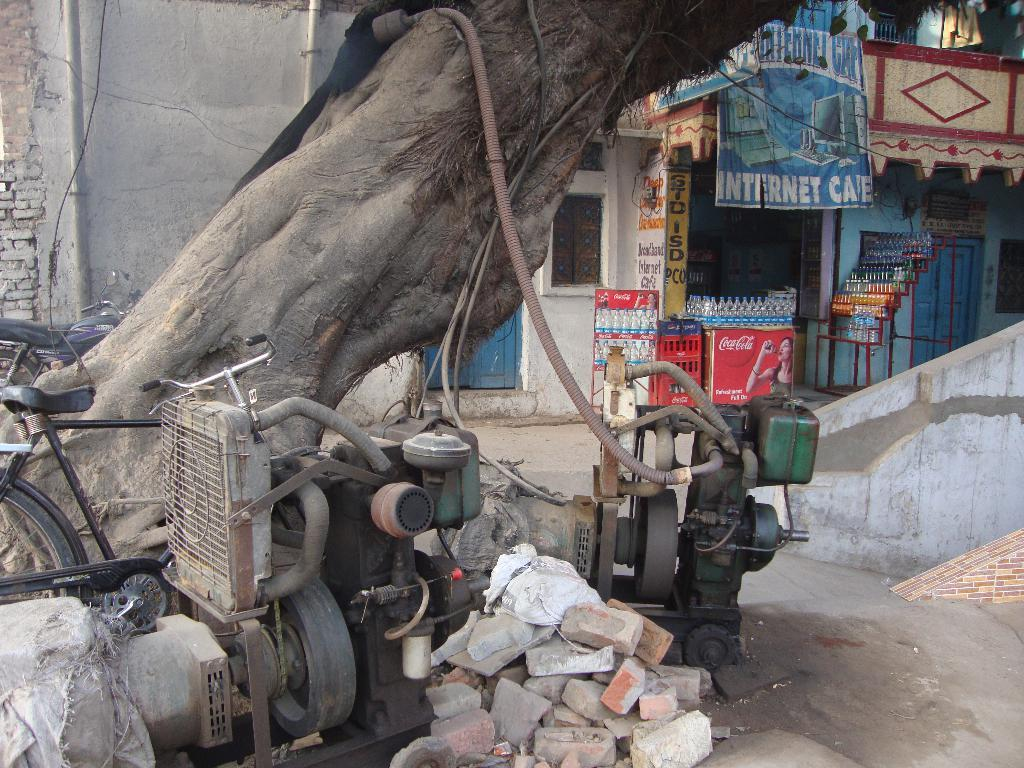What type of plant can be seen in the image? There is a tree in the image. What objects are on the ground in the image? There are machines on the ground in the image. What can be seen on the left side of the image? There are vehicles and a bicycle on the left side of the image. What type of establishment is on the right side of the image? There is a shop on the right side of the image. What items are present in the image that might be used for storage or transportation? There are bottles, crates, and a bicycle in the image. What type of signage is visible in the image? There is a banner in the image. Where is the drain located in the image? There is no drain present in the image. What type of farm animals can be seen grazing in the image? There are no farm animals present in the image. 